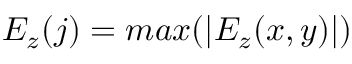Convert formula to latex. <formula><loc_0><loc_0><loc_500><loc_500>E _ { z } ( j ) = \max ( | E _ { z } ( x , y ) | )</formula> 